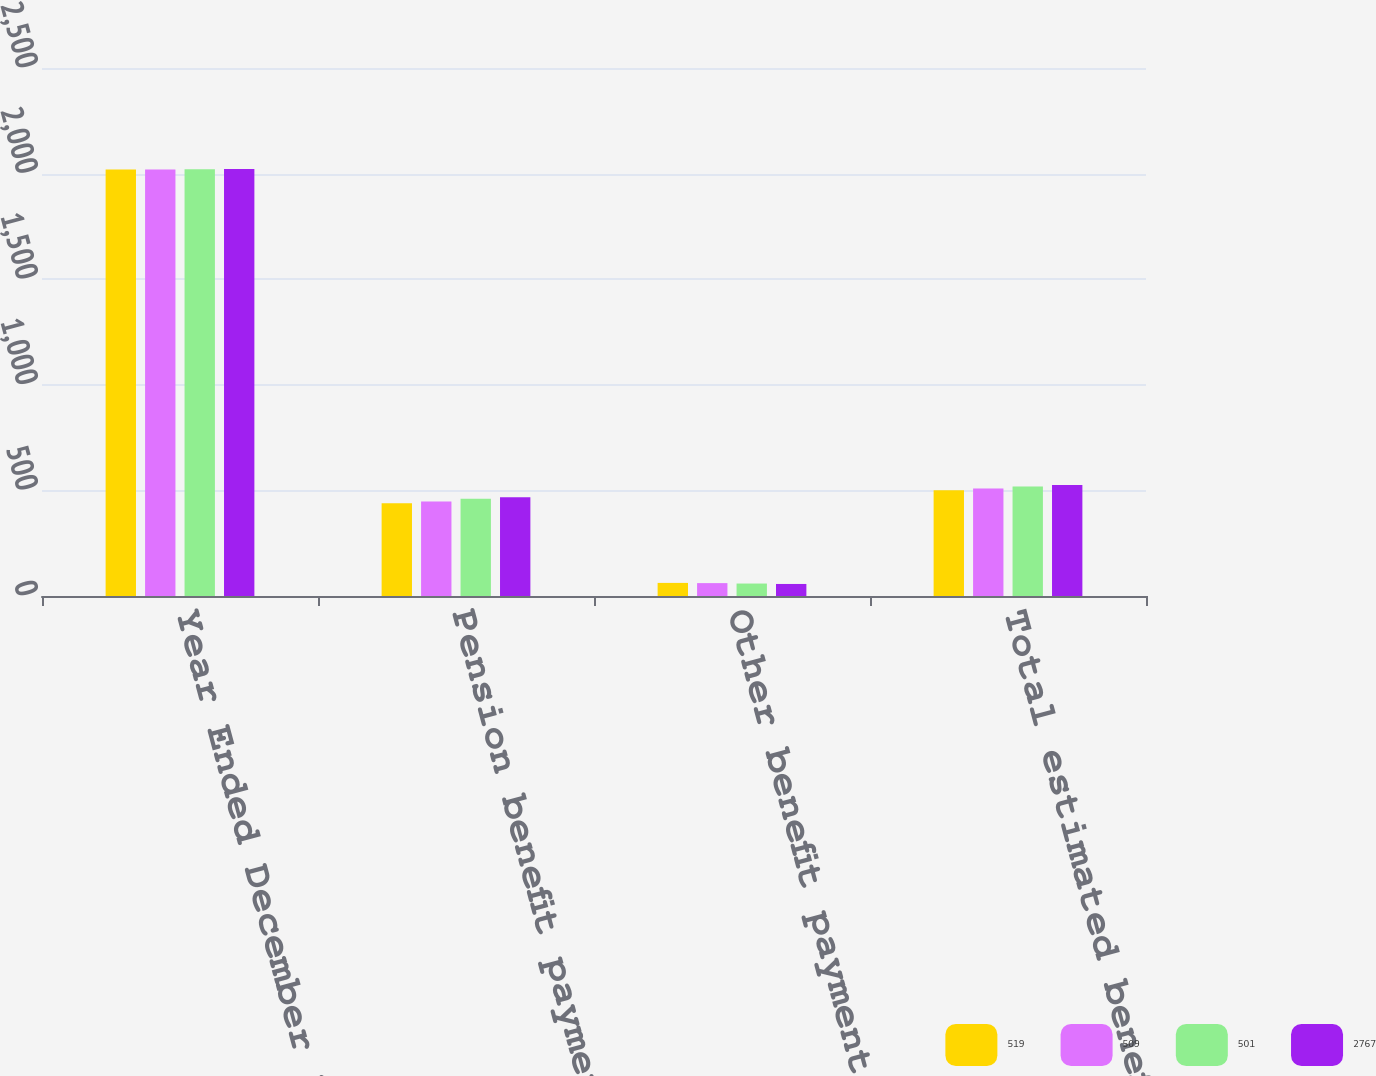Convert chart to OTSL. <chart><loc_0><loc_0><loc_500><loc_500><stacked_bar_chart><ecel><fcel>Year Ended December 31<fcel>Pension benefit payments<fcel>Other benefit payments 1<fcel>Total estimated benefit<nl><fcel>519<fcel>2019<fcel>439<fcel>62<fcel>501<nl><fcel>509<fcel>2020<fcel>448<fcel>61<fcel>509<nl><fcel>501<fcel>2021<fcel>460<fcel>59<fcel>519<nl><fcel>2767<fcel>2022<fcel>468<fcel>57<fcel>525<nl></chart> 